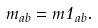Convert formula to latex. <formula><loc_0><loc_0><loc_500><loc_500>m _ { a b } = m { 1 } _ { a b } .</formula> 